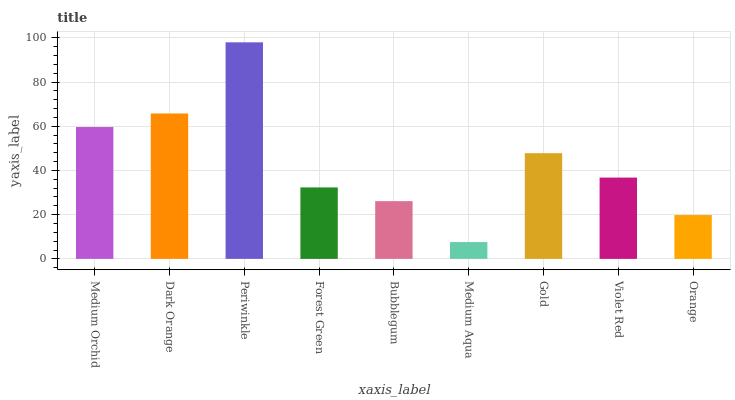Is Medium Aqua the minimum?
Answer yes or no. Yes. Is Periwinkle the maximum?
Answer yes or no. Yes. Is Dark Orange the minimum?
Answer yes or no. No. Is Dark Orange the maximum?
Answer yes or no. No. Is Dark Orange greater than Medium Orchid?
Answer yes or no. Yes. Is Medium Orchid less than Dark Orange?
Answer yes or no. Yes. Is Medium Orchid greater than Dark Orange?
Answer yes or no. No. Is Dark Orange less than Medium Orchid?
Answer yes or no. No. Is Violet Red the high median?
Answer yes or no. Yes. Is Violet Red the low median?
Answer yes or no. Yes. Is Periwinkle the high median?
Answer yes or no. No. Is Periwinkle the low median?
Answer yes or no. No. 